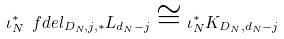Convert formula to latex. <formula><loc_0><loc_0><loc_500><loc_500>\iota _ { N } ^ { * } \ f d e l _ { D _ { N } , j , * } L _ { d _ { N } - j } \cong \iota _ { N } ^ { * } K _ { D _ { N } , d _ { N } - j }</formula> 